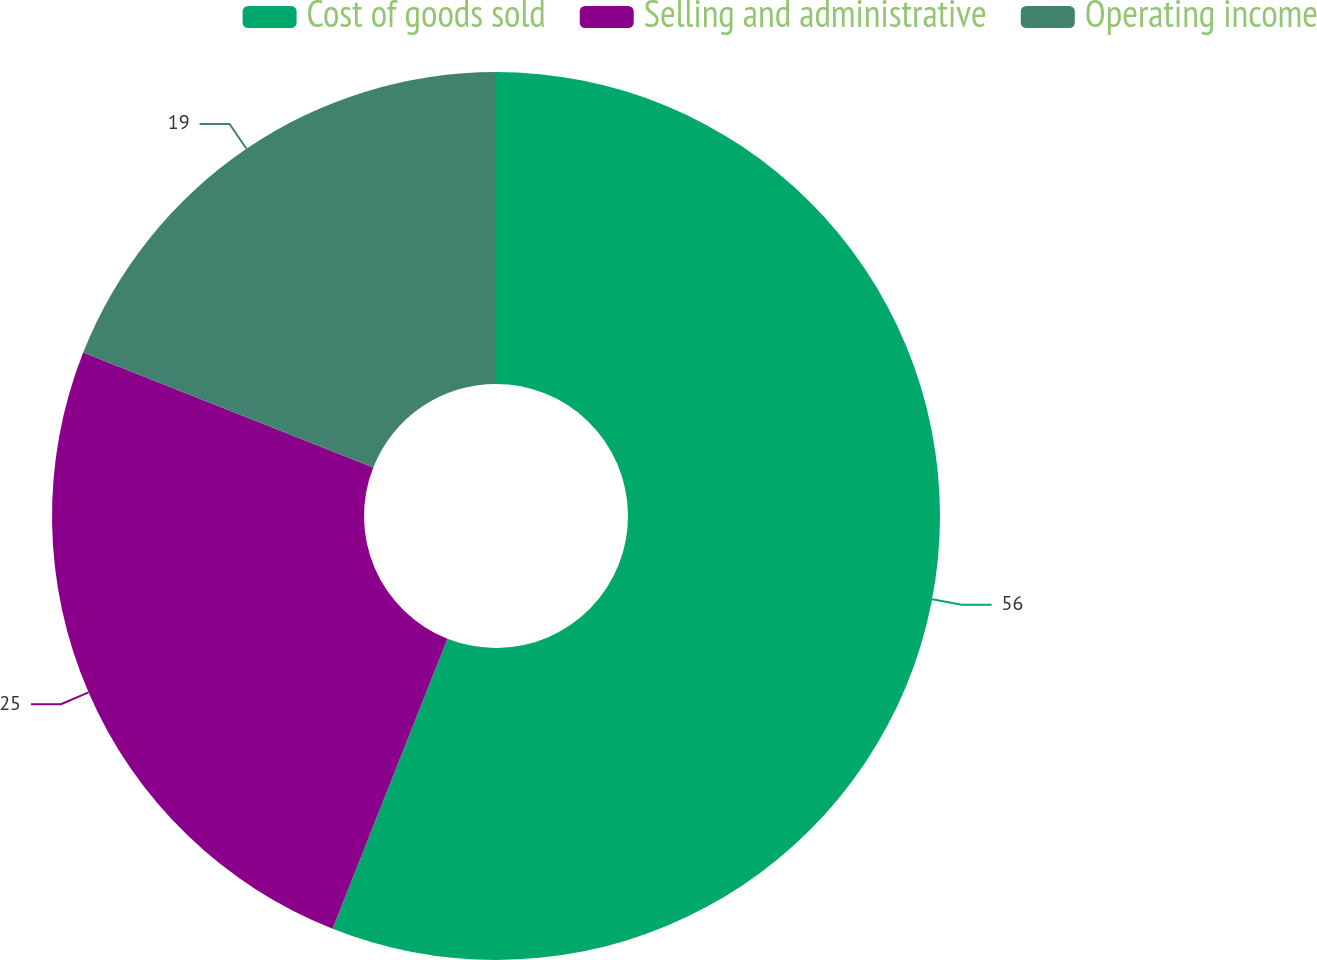Convert chart to OTSL. <chart><loc_0><loc_0><loc_500><loc_500><pie_chart><fcel>Cost of goods sold<fcel>Selling and administrative<fcel>Operating income<nl><fcel>56.0%<fcel>25.0%<fcel>19.0%<nl></chart> 